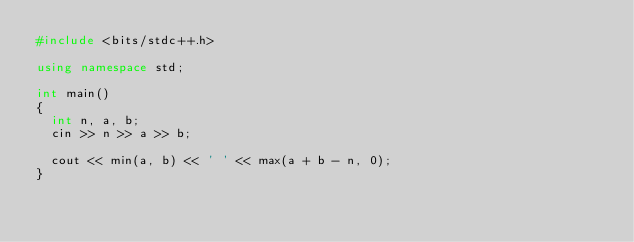Convert code to text. <code><loc_0><loc_0><loc_500><loc_500><_C++_>#include <bits/stdc++.h>

using namespace std;

int main()
{
	int n, a, b;
	cin >> n >> a >> b;
	
	cout << min(a, b) << ' ' << max(a + b - n, 0);
}</code> 